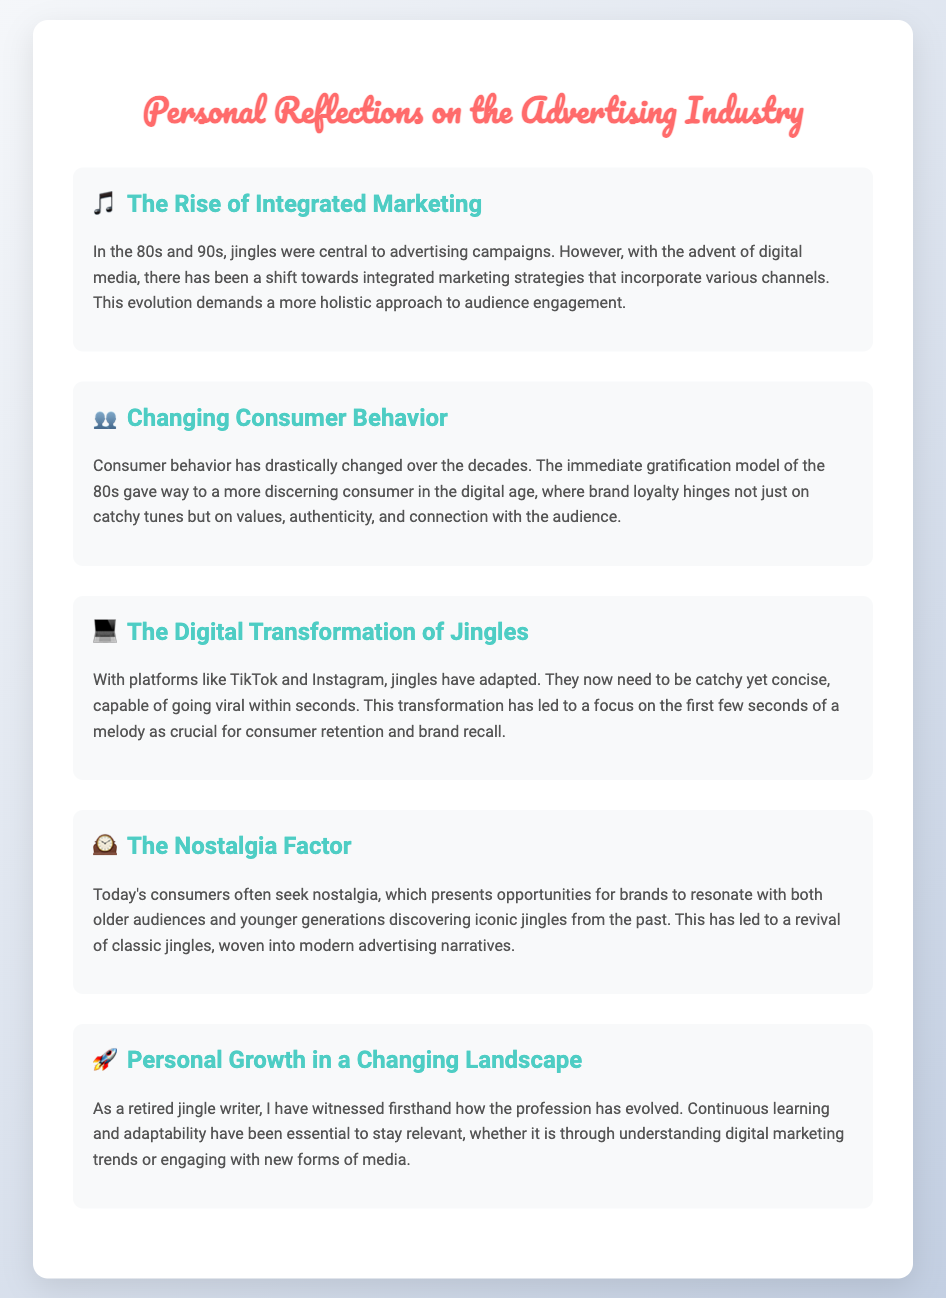What is highlighted as central to advertising campaigns in the 80s and 90s? The document mentions that jingles were central to advertising campaigns during that time.
Answer: jingles What does the evolution of advertising demand according to the reflections? The reflection discusses a shift towards integrated marketing strategies that require a more holistic approach.
Answer: holistic approach In which era did consumer behavior give way to a more discerning model? The document indicates that the immediate gratification model of the 80s changed in the digital age.
Answer: digital age What platforms have influenced the transformation of jingles? The document cites TikTok and Instagram as key platforms for the transformation of jingles.
Answer: TikTok and Instagram What opportunity do brands have today with consumers? The document states that brands can resonate with consumers through nostalgia, appealing to both older and younger generations.
Answer: nostalgia How has the profession of jingle writing evolved according to personal experience? The reflection emphasizes the need for continuous learning and adaptability in the jingle writing profession.
Answer: continuous learning and adaptability 